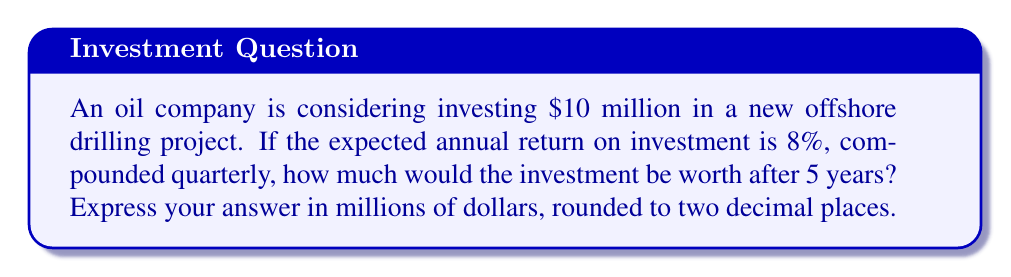Help me with this question. To solve this problem, we'll use the compound interest formula:

$$A = P(1 + \frac{r}{n})^{nt}$$

Where:
$A$ = Final amount
$P$ = Principal (initial investment)
$r$ = Annual interest rate (as a decimal)
$n$ = Number of times interest is compounded per year
$t$ = Number of years

Given:
$P = \$10$ million
$r = 0.08$ (8% expressed as a decimal)
$n = 4$ (compounded quarterly)
$t = 5$ years

Let's substitute these values into the formula:

$$A = 10(1 + \frac{0.08}{4})^{4 \times 5}$$

$$A = 10(1 + 0.02)^{20}$$

$$A = 10(1.02)^{20}$$

Now, we need to calculate $(1.02)^{20}$:

$$(1.02)^{20} \approx 1.4859$$

Multiplying by 10:

$$A = 10 \times 1.4859 \approx 14.859$$

Rounding to two decimal places:

$$A \approx 14.86$$

Therefore, the investment would be worth approximately $14.86 million after 5 years.
Answer: $14.86 million 